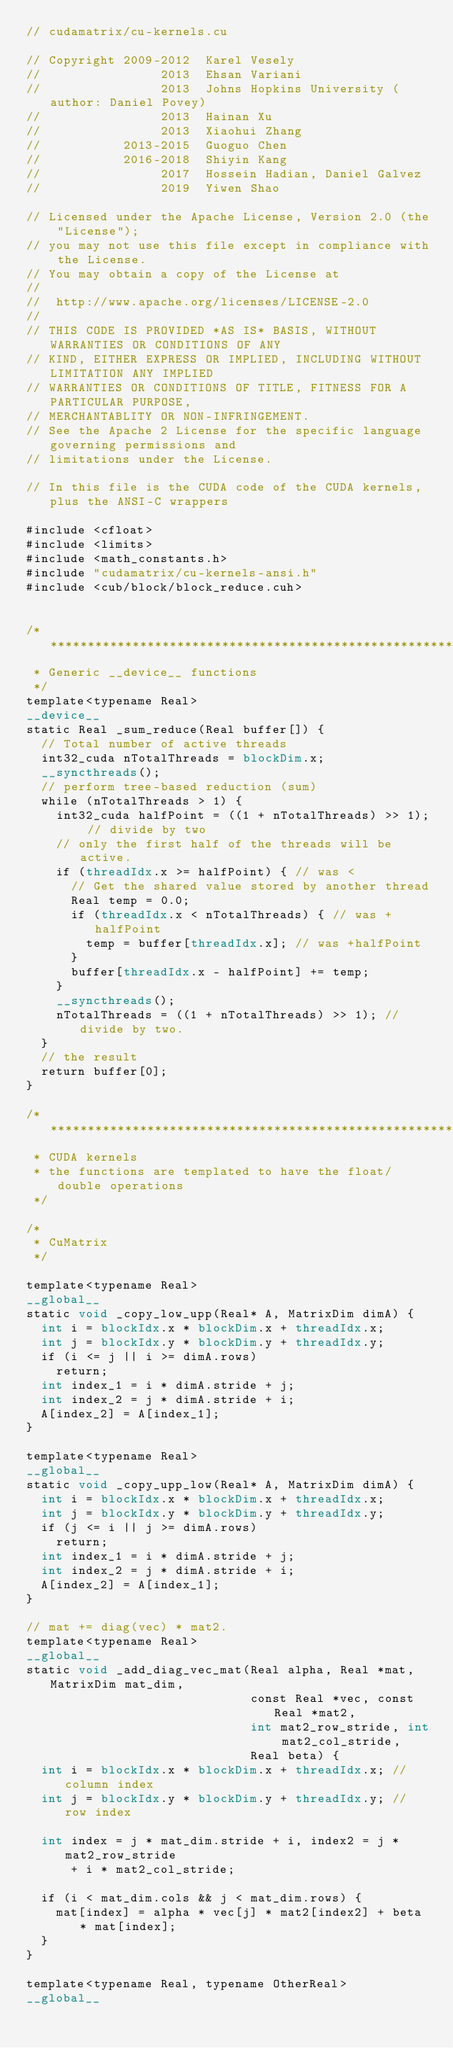<code> <loc_0><loc_0><loc_500><loc_500><_Cuda_>// cudamatrix/cu-kernels.cu

// Copyright 2009-2012  Karel Vesely
//                2013  Ehsan Variani
//                2013  Johns Hopkins University (author: Daniel Povey)
//                2013  Hainan Xu
//                2013  Xiaohui Zhang
//           2013-2015  Guoguo Chen
//           2016-2018  Shiyin Kang
//                2017  Hossein Hadian, Daniel Galvez
//                2019  Yiwen Shao

// Licensed under the Apache License, Version 2.0 (the "License");
// you may not use this file except in compliance with the License.
// You may obtain a copy of the License at
//
//  http://www.apache.org/licenses/LICENSE-2.0
//
// THIS CODE IS PROVIDED *AS IS* BASIS, WITHOUT WARRANTIES OR CONDITIONS OF ANY
// KIND, EITHER EXPRESS OR IMPLIED, INCLUDING WITHOUT LIMITATION ANY IMPLIED
// WARRANTIES OR CONDITIONS OF TITLE, FITNESS FOR A PARTICULAR PURPOSE,
// MERCHANTABLITY OR NON-INFRINGEMENT.
// See the Apache 2 License for the specific language governing permissions and
// limitations under the License.

// In this file is the CUDA code of the CUDA kernels, plus the ANSI-C wrappers

#include <cfloat>
#include <limits>
#include <math_constants.h>
#include "cudamatrix/cu-kernels-ansi.h"
#include <cub/block/block_reduce.cuh>


/***********************************************************************
 * Generic __device__ functions
 */
template<typename Real>
__device__
static Real _sum_reduce(Real buffer[]) {
  // Total number of active threads
  int32_cuda nTotalThreads = blockDim.x;
  __syncthreads();
  // perform tree-based reduction (sum)
  while (nTotalThreads > 1) {
    int32_cuda halfPoint = ((1 + nTotalThreads) >> 1); // divide by two
    // only the first half of the threads will be active.
    if (threadIdx.x >= halfPoint) { // was <
      // Get the shared value stored by another thread
      Real temp = 0.0;
      if (threadIdx.x < nTotalThreads) { // was +halfPoint
        temp = buffer[threadIdx.x]; // was +halfPoint
      }
      buffer[threadIdx.x - halfPoint] += temp;
    }
    __syncthreads();
    nTotalThreads = ((1 + nTotalThreads) >> 1); // divide by two.
  }
  // the result
  return buffer[0];
}

/***********************************************************************
 * CUDA kernels
 * the functions are templated to have the float/double operations
 */

/*
 * CuMatrix
 */

template<typename Real>
__global__
static void _copy_low_upp(Real* A, MatrixDim dimA) {
  int i = blockIdx.x * blockDim.x + threadIdx.x;
  int j = blockIdx.y * blockDim.y + threadIdx.y;
  if (i <= j || i >= dimA.rows)
    return;
  int index_1 = i * dimA.stride + j;
  int index_2 = j * dimA.stride + i;
  A[index_2] = A[index_1];
}

template<typename Real>
__global__
static void _copy_upp_low(Real* A, MatrixDim dimA) {
  int i = blockIdx.x * blockDim.x + threadIdx.x;
  int j = blockIdx.y * blockDim.y + threadIdx.y;
  if (j <= i || j >= dimA.rows)
    return;
  int index_1 = i * dimA.stride + j;
  int index_2 = j * dimA.stride + i;
  A[index_2] = A[index_1];
}

// mat += diag(vec) * mat2.
template<typename Real>
__global__
static void _add_diag_vec_mat(Real alpha, Real *mat, MatrixDim mat_dim,
                              const Real *vec, const Real *mat2,
                              int mat2_row_stride, int mat2_col_stride,
                              Real beta) {
  int i = blockIdx.x * blockDim.x + threadIdx.x; // column index
  int j = blockIdx.y * blockDim.y + threadIdx.y; // row index

  int index = j * mat_dim.stride + i, index2 = j * mat2_row_stride
      + i * mat2_col_stride;

  if (i < mat_dim.cols && j < mat_dim.rows) {
    mat[index] = alpha * vec[j] * mat2[index2] + beta * mat[index];
  }
}

template<typename Real, typename OtherReal>
__global__</code> 